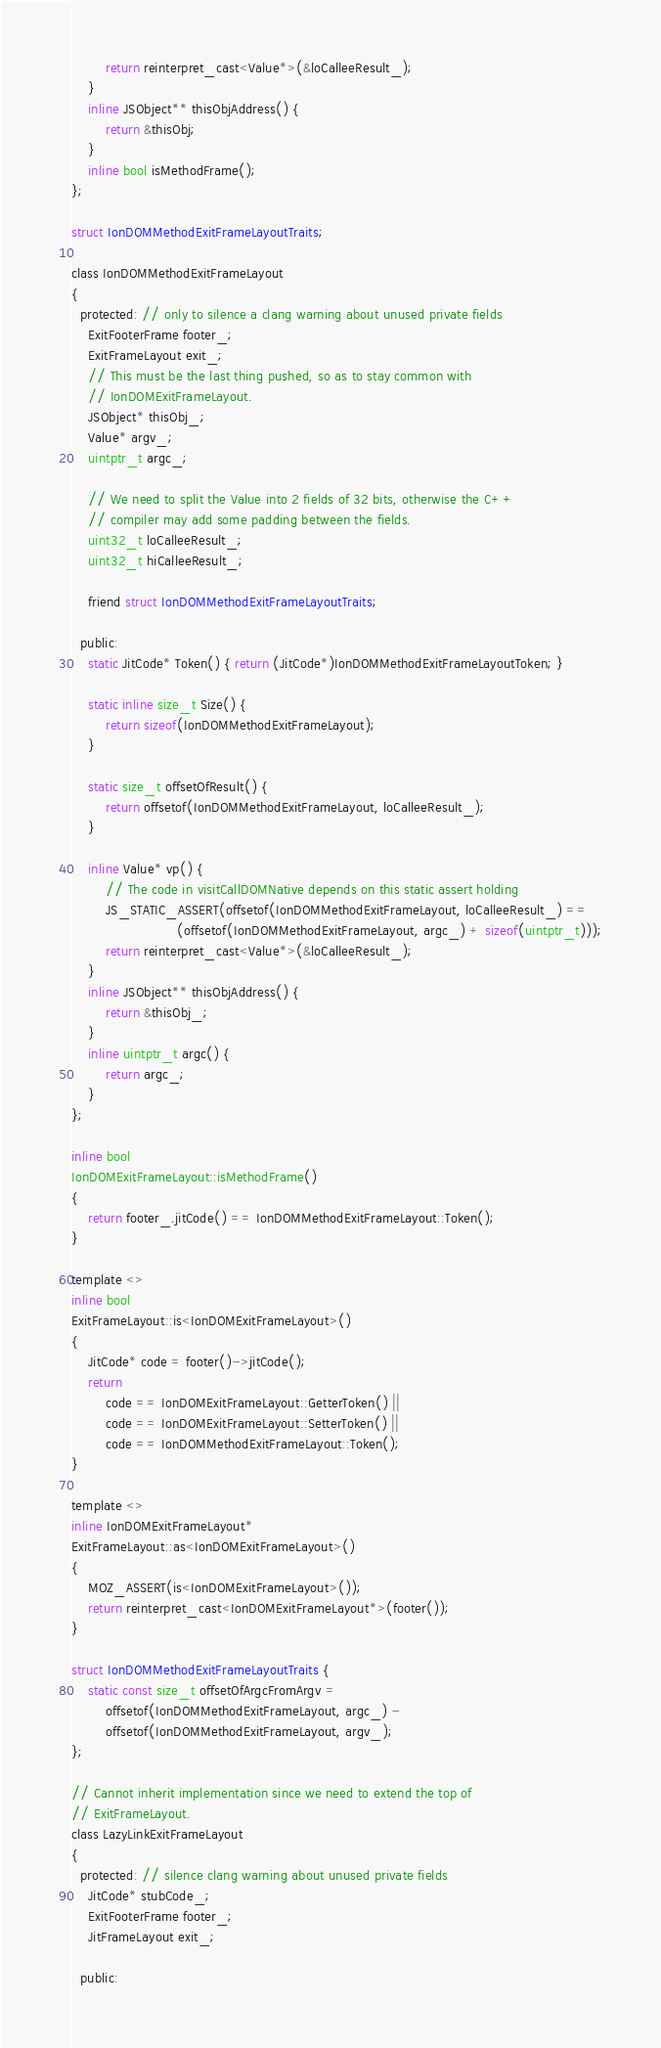<code> <loc_0><loc_0><loc_500><loc_500><_C_>        return reinterpret_cast<Value*>(&loCalleeResult_);
    }
    inline JSObject** thisObjAddress() {
        return &thisObj;
    }
    inline bool isMethodFrame();
};

struct IonDOMMethodExitFrameLayoutTraits;

class IonDOMMethodExitFrameLayout
{
  protected: // only to silence a clang warning about unused private fields
    ExitFooterFrame footer_;
    ExitFrameLayout exit_;
    // This must be the last thing pushed, so as to stay common with
    // IonDOMExitFrameLayout.
    JSObject* thisObj_;
    Value* argv_;
    uintptr_t argc_;

    // We need to split the Value into 2 fields of 32 bits, otherwise the C++
    // compiler may add some padding between the fields.
    uint32_t loCalleeResult_;
    uint32_t hiCalleeResult_;

    friend struct IonDOMMethodExitFrameLayoutTraits;

  public:
    static JitCode* Token() { return (JitCode*)IonDOMMethodExitFrameLayoutToken; }

    static inline size_t Size() {
        return sizeof(IonDOMMethodExitFrameLayout);
    }

    static size_t offsetOfResult() {
        return offsetof(IonDOMMethodExitFrameLayout, loCalleeResult_);
    }

    inline Value* vp() {
        // The code in visitCallDOMNative depends on this static assert holding
        JS_STATIC_ASSERT(offsetof(IonDOMMethodExitFrameLayout, loCalleeResult_) ==
                         (offsetof(IonDOMMethodExitFrameLayout, argc_) + sizeof(uintptr_t)));
        return reinterpret_cast<Value*>(&loCalleeResult_);
    }
    inline JSObject** thisObjAddress() {
        return &thisObj_;
    }
    inline uintptr_t argc() {
        return argc_;
    }
};

inline bool
IonDOMExitFrameLayout::isMethodFrame()
{
    return footer_.jitCode() == IonDOMMethodExitFrameLayout::Token();
}

template <>
inline bool
ExitFrameLayout::is<IonDOMExitFrameLayout>()
{
    JitCode* code = footer()->jitCode();
    return
        code == IonDOMExitFrameLayout::GetterToken() ||
        code == IonDOMExitFrameLayout::SetterToken() ||
        code == IonDOMMethodExitFrameLayout::Token();
}

template <>
inline IonDOMExitFrameLayout*
ExitFrameLayout::as<IonDOMExitFrameLayout>()
{
    MOZ_ASSERT(is<IonDOMExitFrameLayout>());
    return reinterpret_cast<IonDOMExitFrameLayout*>(footer());
}

struct IonDOMMethodExitFrameLayoutTraits {
    static const size_t offsetOfArgcFromArgv =
        offsetof(IonDOMMethodExitFrameLayout, argc_) -
        offsetof(IonDOMMethodExitFrameLayout, argv_);
};

// Cannot inherit implementation since we need to extend the top of
// ExitFrameLayout.
class LazyLinkExitFrameLayout
{
  protected: // silence clang warning about unused private fields
    JitCode* stubCode_;
    ExitFooterFrame footer_;
    JitFrameLayout exit_;

  public:</code> 